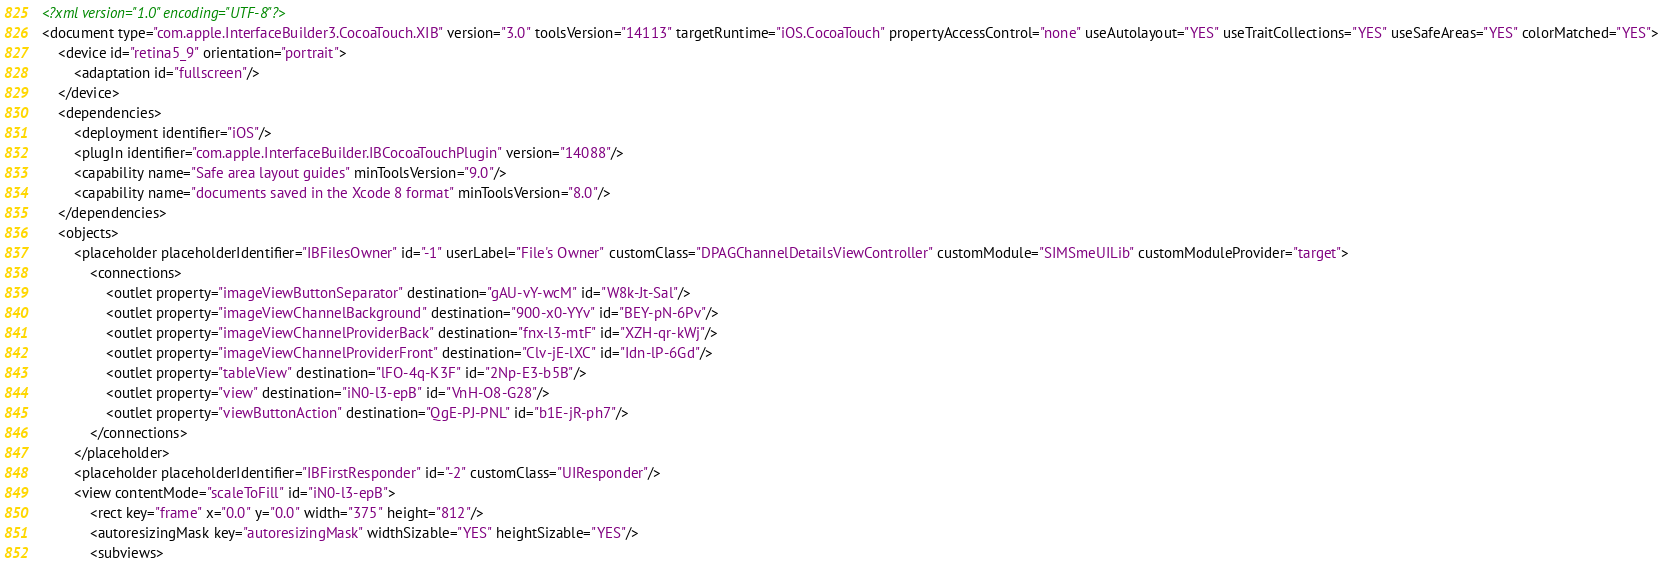<code> <loc_0><loc_0><loc_500><loc_500><_XML_><?xml version="1.0" encoding="UTF-8"?>
<document type="com.apple.InterfaceBuilder3.CocoaTouch.XIB" version="3.0" toolsVersion="14113" targetRuntime="iOS.CocoaTouch" propertyAccessControl="none" useAutolayout="YES" useTraitCollections="YES" useSafeAreas="YES" colorMatched="YES">
    <device id="retina5_9" orientation="portrait">
        <adaptation id="fullscreen"/>
    </device>
    <dependencies>
        <deployment identifier="iOS"/>
        <plugIn identifier="com.apple.InterfaceBuilder.IBCocoaTouchPlugin" version="14088"/>
        <capability name="Safe area layout guides" minToolsVersion="9.0"/>
        <capability name="documents saved in the Xcode 8 format" minToolsVersion="8.0"/>
    </dependencies>
    <objects>
        <placeholder placeholderIdentifier="IBFilesOwner" id="-1" userLabel="File's Owner" customClass="DPAGChannelDetailsViewController" customModule="SIMSmeUILib" customModuleProvider="target">
            <connections>
                <outlet property="imageViewButtonSeparator" destination="gAU-vY-wcM" id="W8k-Jt-Sal"/>
                <outlet property="imageViewChannelBackground" destination="900-x0-YYv" id="BEY-pN-6Pv"/>
                <outlet property="imageViewChannelProviderBack" destination="fnx-l3-mtF" id="XZH-qr-kWj"/>
                <outlet property="imageViewChannelProviderFront" destination="Clv-jE-lXC" id="Idn-lP-6Gd"/>
                <outlet property="tableView" destination="lFO-4q-K3F" id="2Np-E3-b5B"/>
                <outlet property="view" destination="iN0-l3-epB" id="VnH-O8-G28"/>
                <outlet property="viewButtonAction" destination="QgE-PJ-PNL" id="b1E-jR-ph7"/>
            </connections>
        </placeholder>
        <placeholder placeholderIdentifier="IBFirstResponder" id="-2" customClass="UIResponder"/>
        <view contentMode="scaleToFill" id="iN0-l3-epB">
            <rect key="frame" x="0.0" y="0.0" width="375" height="812"/>
            <autoresizingMask key="autoresizingMask" widthSizable="YES" heightSizable="YES"/>
            <subviews></code> 